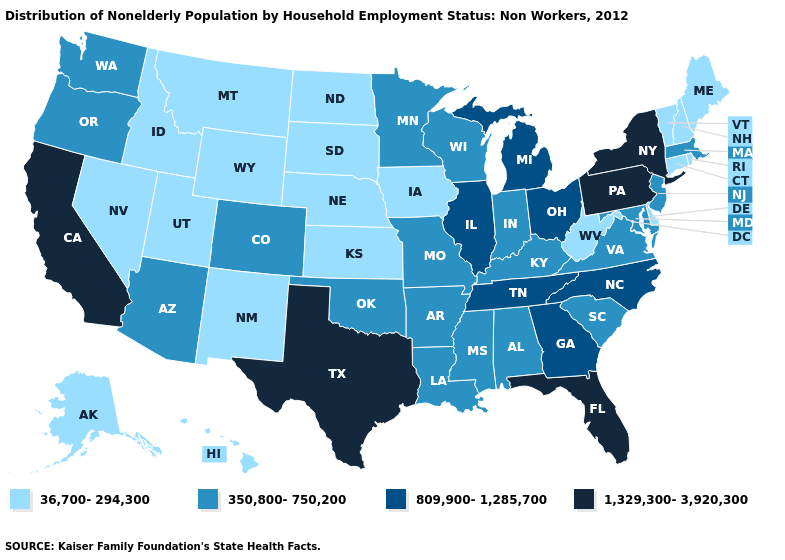What is the value of Kansas?
Quick response, please. 36,700-294,300. Among the states that border North Carolina , which have the lowest value?
Quick response, please. South Carolina, Virginia. What is the highest value in the USA?
Answer briefly. 1,329,300-3,920,300. Does Texas have the highest value in the USA?
Give a very brief answer. Yes. Does Kansas have the same value as Maine?
Give a very brief answer. Yes. Among the states that border Oregon , which have the highest value?
Short answer required. California. Among the states that border Connecticut , does Massachusetts have the lowest value?
Keep it brief. No. Name the states that have a value in the range 809,900-1,285,700?
Quick response, please. Georgia, Illinois, Michigan, North Carolina, Ohio, Tennessee. What is the highest value in states that border Arizona?
Answer briefly. 1,329,300-3,920,300. Does Kansas have a higher value than Delaware?
Quick response, please. No. Name the states that have a value in the range 1,329,300-3,920,300?
Answer briefly. California, Florida, New York, Pennsylvania, Texas. Name the states that have a value in the range 809,900-1,285,700?
Write a very short answer. Georgia, Illinois, Michigan, North Carolina, Ohio, Tennessee. Does Minnesota have the highest value in the MidWest?
Answer briefly. No. What is the lowest value in the West?
Keep it brief. 36,700-294,300. 